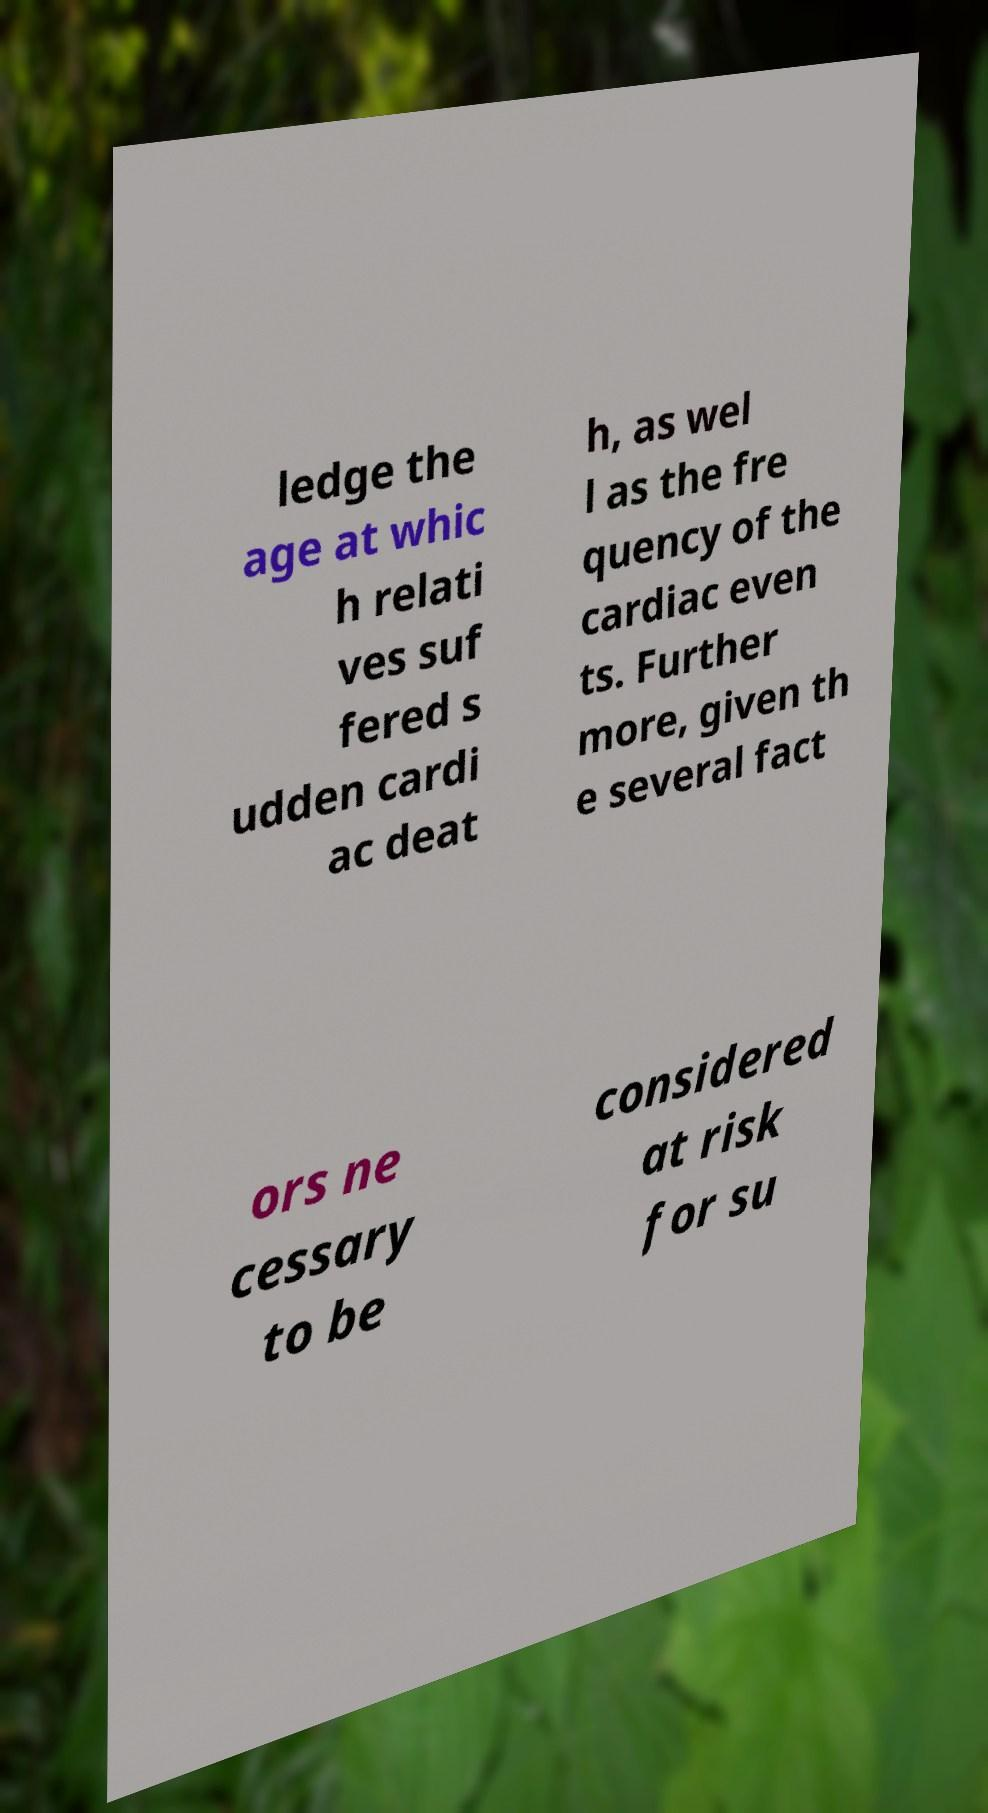Could you assist in decoding the text presented in this image and type it out clearly? ledge the age at whic h relati ves suf fered s udden cardi ac deat h, as wel l as the fre quency of the cardiac even ts. Further more, given th e several fact ors ne cessary to be considered at risk for su 